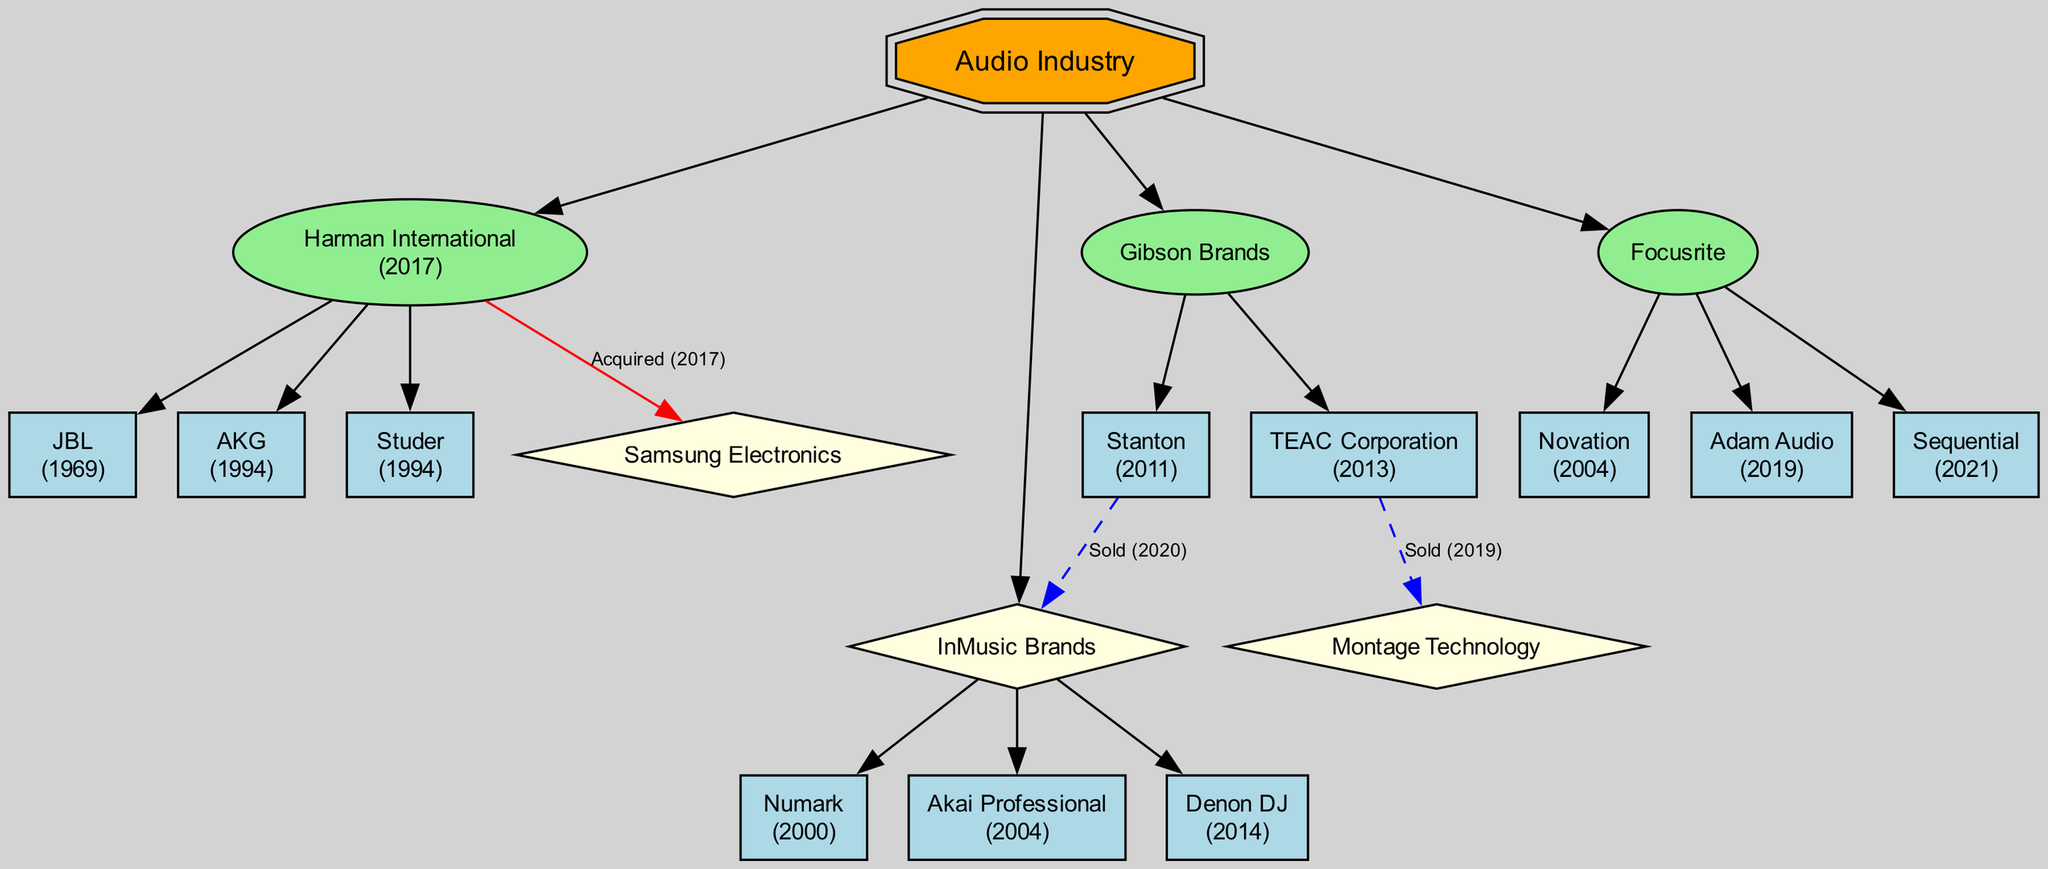What is the root node of the family tree? The root node is labeled as "Audio Industry". It represents the main topic from which all other manufacturers and their relationships branch out.
Answer: Audio Industry How many children does Harman International have? Harman International has three children listed in the diagram: JBL, AKG, and Studer. Counting them provides the answer to the question.
Answer: 3 Who is the parent company of JBL? The parent company of JBL, as indicated in the diagram, is Harman International. It shows the hierarchical relationship with JBL as one of its children.
Answer: Harman International In what year did Gibson Brands acquire Stanton? According to the diagram, Stanton was acquired by Gibson Brands in the year 2011. This can be found directly next to Stanton in the family tree.
Answer: 2011 How many companies did InMusic Brands acquire? InMusic Brands acquired three companies: Numark, Akai Professional, and Denon DJ. The diagram clearly lists these as children of InMusic Brands, which leads to the total count of three acquisitions.
Answer: 3 Who sold TEAC Corporation and in what year? TEAC Corporation was sold to Montage Technology in the year 2019. This information can be seen in the diagram where TEAC Corporation is shown under Gibson Brands, along with the details of its sale.
Answer: Montage Technology, 2019 Which company acquired Harman International? The diagram indicates that Harman International was acquired by Samsung Electronics in the year 2017. This is specified through the link from Harman International to Samsung Electronics in the diagram.
Answer: Samsung Electronics Identify the acquisition year of Akai Professional by InMusic Brands. In the diagram, Akai Professional is noted to have been acquired by InMusic Brands in 2004. This information is found next to the name Akai Professional in the family tree.
Answer: 2004 How is the relationship between Gibson Brands and Stanton characterized after 2020? After 2020, the relationship between Gibson Brands and Stanton is characterized as 'Sold' to InMusic Brands, indicating a change in ownership rather than acquisition. This detail is shown through the dashed line connecting Stanton to InMusic Brands.
Answer: Sold to InMusic Brands 